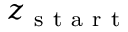Convert formula to latex. <formula><loc_0><loc_0><loc_500><loc_500>z _ { s t a r t }</formula> 